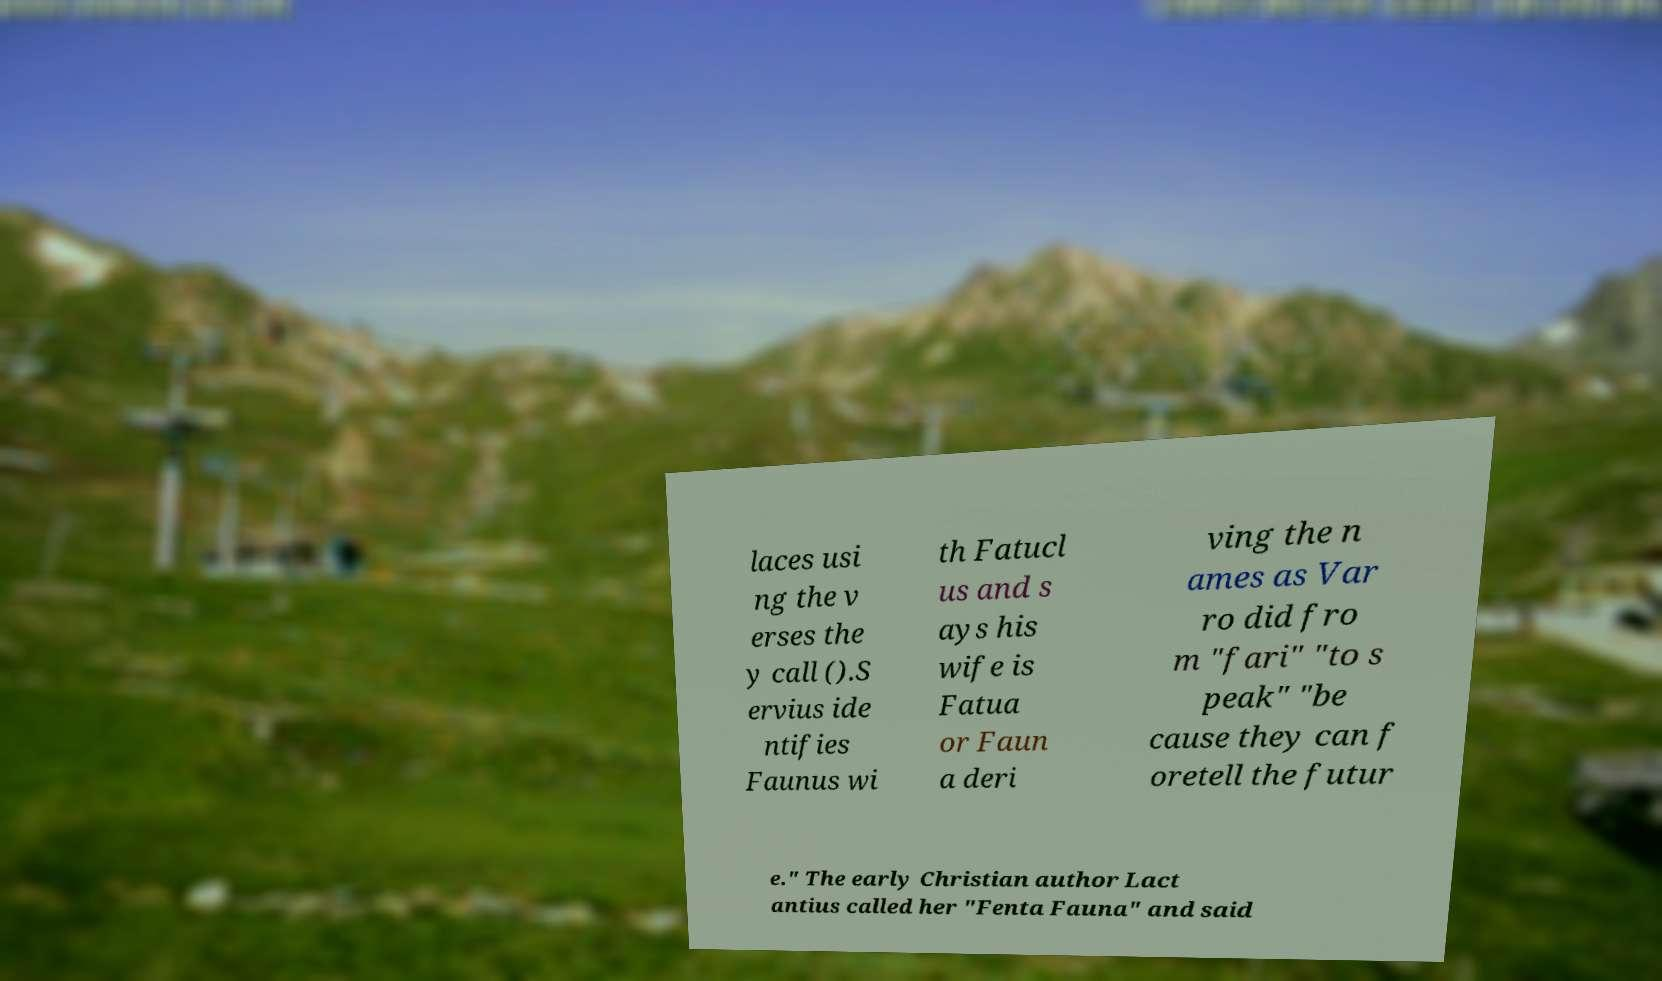For documentation purposes, I need the text within this image transcribed. Could you provide that? laces usi ng the v erses the y call ().S ervius ide ntifies Faunus wi th Fatucl us and s ays his wife is Fatua or Faun a deri ving the n ames as Var ro did fro m "fari" "to s peak" "be cause they can f oretell the futur e." The early Christian author Lact antius called her "Fenta Fauna" and said 